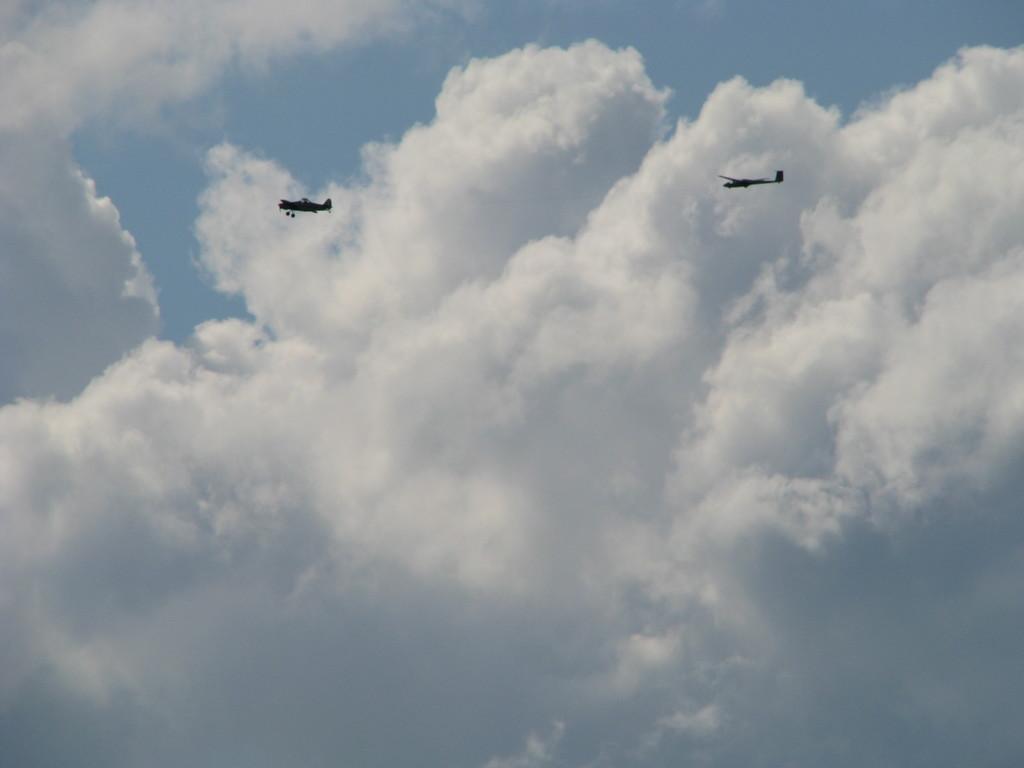Can you describe this image briefly? In this image we can see aeroplanes flying in the air. In the background we can see sky and clouds. 